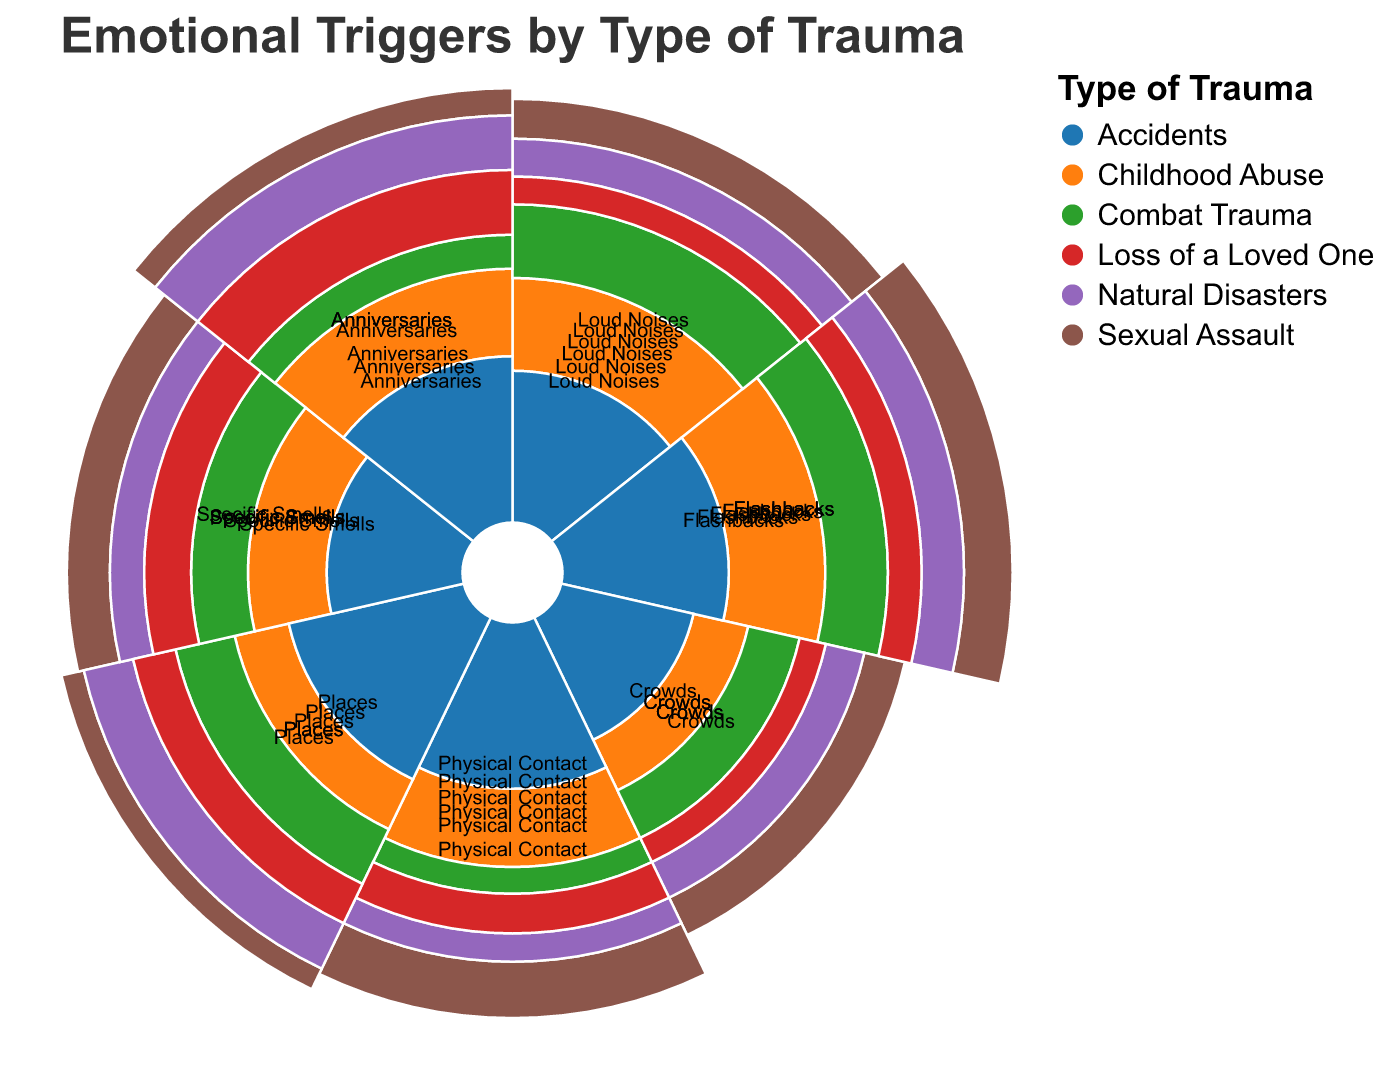What are the emotional triggers associated with Childhood Abuse? To find the emotional triggers associated with Childhood Abuse, locate the segment labeled "Childhood Abuse" and identify the triggers and their respective values in the polar chart.
Answer: Loud Noises: 8, Flashbacks: 9, Crowds: 4, Physical Contact: 7, Places: 5, Specific Smells: 6, Anniversaries: 8 Which trauma type has the highest trigger value for Anniversaries? Compare the values for Anniversaries across all trauma types. Identify which value is the highest.
Answer: Loss of a Loved One What is the most common emotional trigger for Sexual Assault? To determine the most common trigger for Sexual Assault, look at all the values under Sexual Assault and identify the highest one.
Answer: Flashbacks and Physical Contact Compare the trigger value for Loud Noises between Childhood Abuse and Combat Trauma. Identify the values for Loud Noises under Childhood Abuse and Combat Trauma, and then compare them.
Answer: Childhood Abuse: 8, Combat Trauma: 9; Combat Trauma is higher Which trauma type exhibits the lowest sensitivity to Crowds? Compare the values for Crowds across all trauma types and identify the lowest value.
Answer: Loss of a Loved One What's the average trigger value for Specific Smells across all trauma types? Sum the values for Specific Smells for all trauma types and divide by the number of trauma types. (6 + 6 + 7 + 5 + 4 + 6)/6 = 34/6
Answer: 5.67 How does the trigger value for Flashbacks in Natural Disasters compare to that in Sexual Assault? Identify the values for Flashbacks under Natural Disasters and Sexual Assault, then compare them.
Answer: Natural Disasters: 7, Sexual Assault: 9; Sexual Assault is higher What is the range of values for Places as a trigger across all trauma types? Find the minimum and maximum values for Places across all trauma types and calculate the difference. Maximum is 8 (Natural Disasters), Minimum is 4 (Sexual Assault). Range = 8 - 4
Answer: 4 Which trigger is equally common among Combat Trauma and Accidents? Compare the values for all triggers under Combat Trauma and Accidents to find any that have the same value.
Answer: Specific Smells (both 6) How does the trigger sensitivity for Physical Contact in Childhood Abuse compare to that in Accidents? Locate the values for Physical Contact under both Childhood Abuse and Accidents and compare them.
Answer: Childhood Abuse: 7, Accidents: 6; Childhood Abuse is higher 